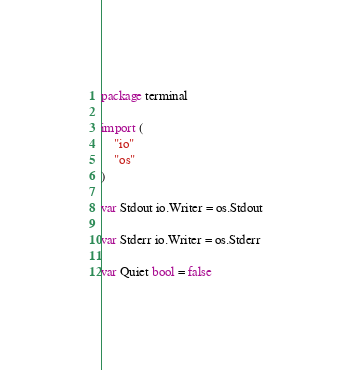<code> <loc_0><loc_0><loc_500><loc_500><_Go_>package terminal

import (
	"io"
	"os"
)

var Stdout io.Writer = os.Stdout

var Stderr io.Writer = os.Stderr

var Quiet bool = false
</code> 